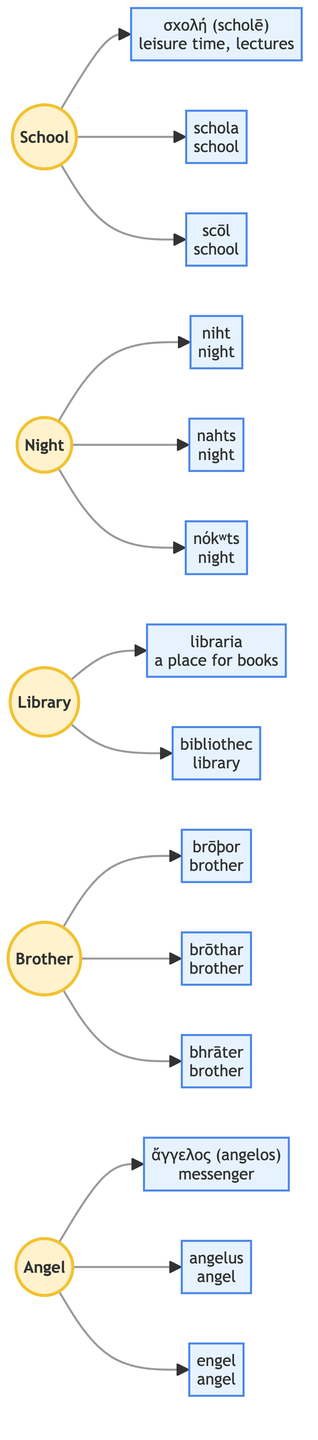What are the origins of the word "School"? The word "School" has three origins listed in the diagram: Greek, Latin, and Old English. The specific words are σκολή (scholē), schola, and scōl, respectively.
Answer: Greek, Latin, Old English How many total origin languages are represented for the word "Brother"? The word "Brother" has three origin languages displayed in the flowchart: Old English, Germanic, and Proto-Indo-European.
Answer: 3 Which language does the etymology of "Library" connect to? The word "Library" connects to two languages: Latin and Old English. The specific origins are libraria and bibliothec.
Answer: Latin, Old English What is the Greek origin of the word "Angel"? The Greek origin of the word "Angel" is the word ἄγγελος (angelos), meaning "messenger."
Answer: ἄγγελος (angelos) What is the Proto-Indo-European origin of the word "Night"? The Proto-Indo-European origin corresponds to the word "nókʷts," which signifies "night."
Answer: ногʷts How many words trace back to Old English in this diagram? In total, four words trace back to Old English: School, Night, Library, and Brother.
Answer: 4 Which word has an origin from each of the three languages: Greek, Latin, and Old English? The word "School" has origins from Greek (σχολή), Latin (schola), and Old English (scōl).
Answer: School What is the Germanic origin of the word "Brother"? The Germanic origin of the word "Brother" is "brōthar," which also means "brother."
Answer: brōthar What does the Latin origin "libraria" mean? The Latin origin "libraria" means "a place for books."
Answer: a place for books 